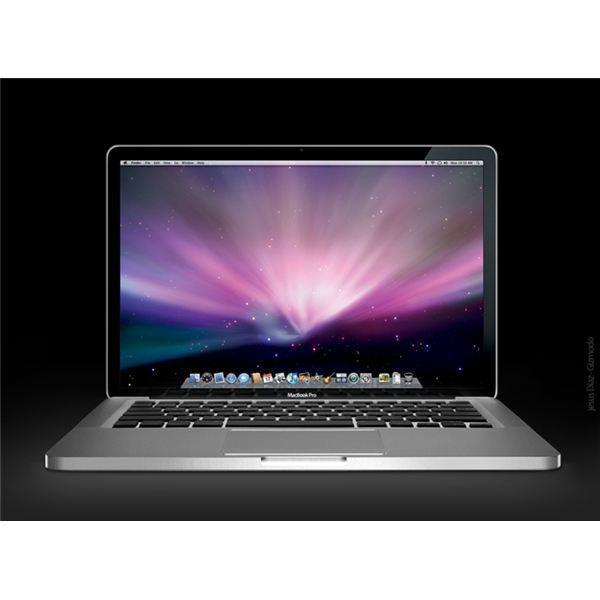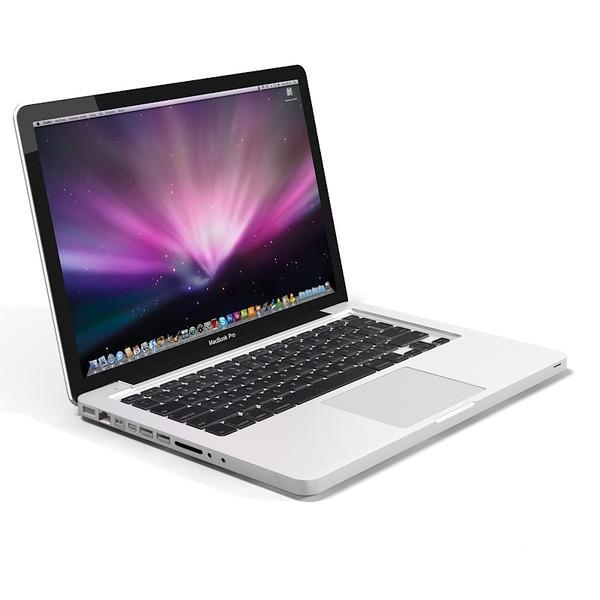The first image is the image on the left, the second image is the image on the right. Evaluate the accuracy of this statement regarding the images: "In at least one of the photos, the screen is seen bent in at a sharp angle.". Is it true? Answer yes or no. No. The first image is the image on the left, the second image is the image on the right. For the images displayed, is the sentence "The logo on the back of the laptop is clearly visible in at least one image." factually correct? Answer yes or no. No. 